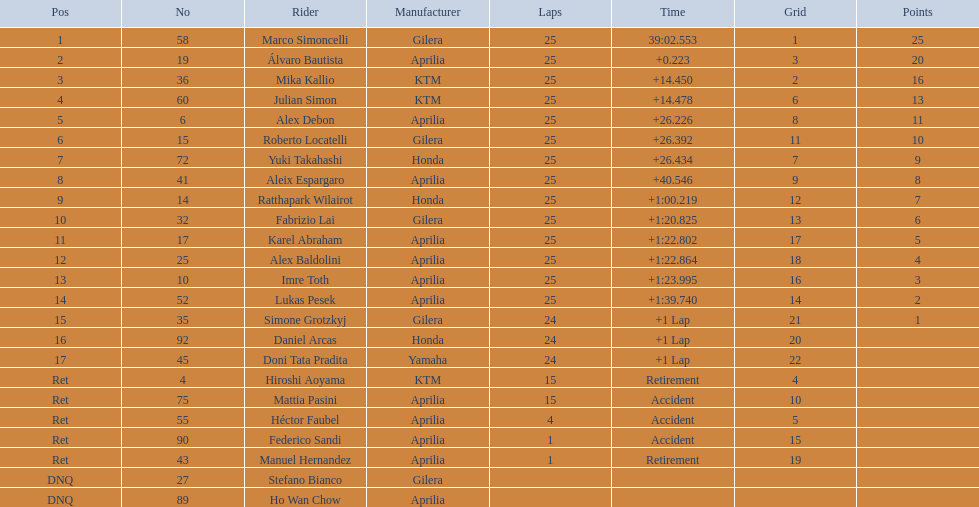How many laps did marco perform? 25. How many laps did hiroshi perform? 15. Which of these numbers are higher? 25. Who swam this number of laps? Marco Simoncelli. 